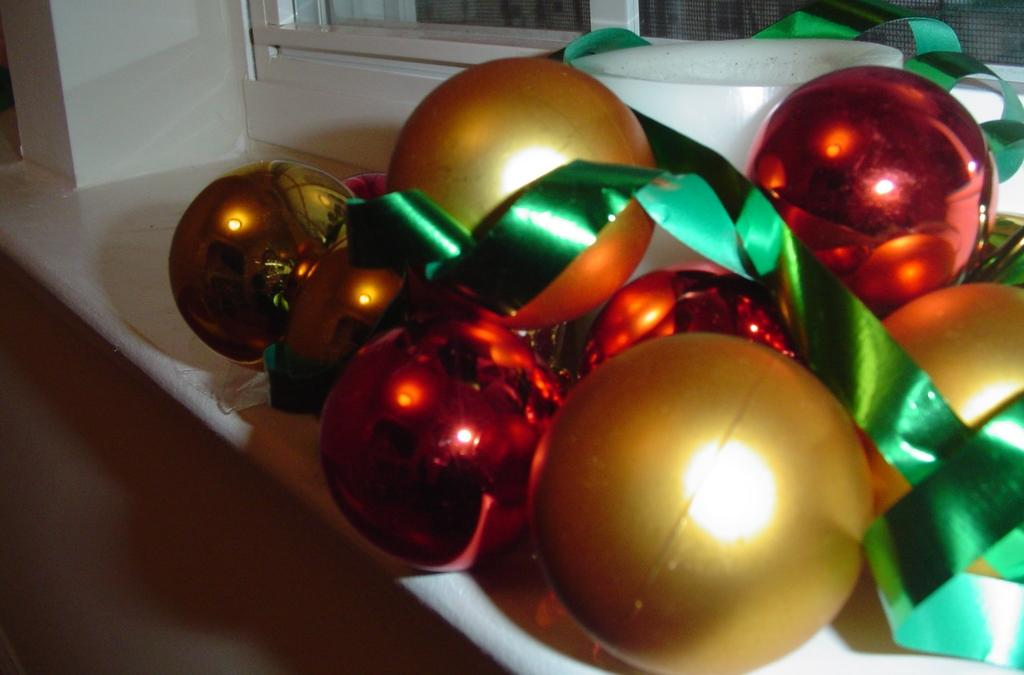What objects are present in the image? There are balls and ribbons in the image. How are the balls and ribbons arranged? The balls and ribbons are placed on a rack. What can be seen in the background of the image? There is a window visible in the image. What type of structure is the window part of? The window is part of a building. Can you tell me how many mountains are visible in the image? There are no mountains visible in the image; it features a window that is part of a building. What type of conversation is happening between the balls and ribbons in the image? There is no conversation happening between the balls and ribbons in the image, as they are inanimate objects. 